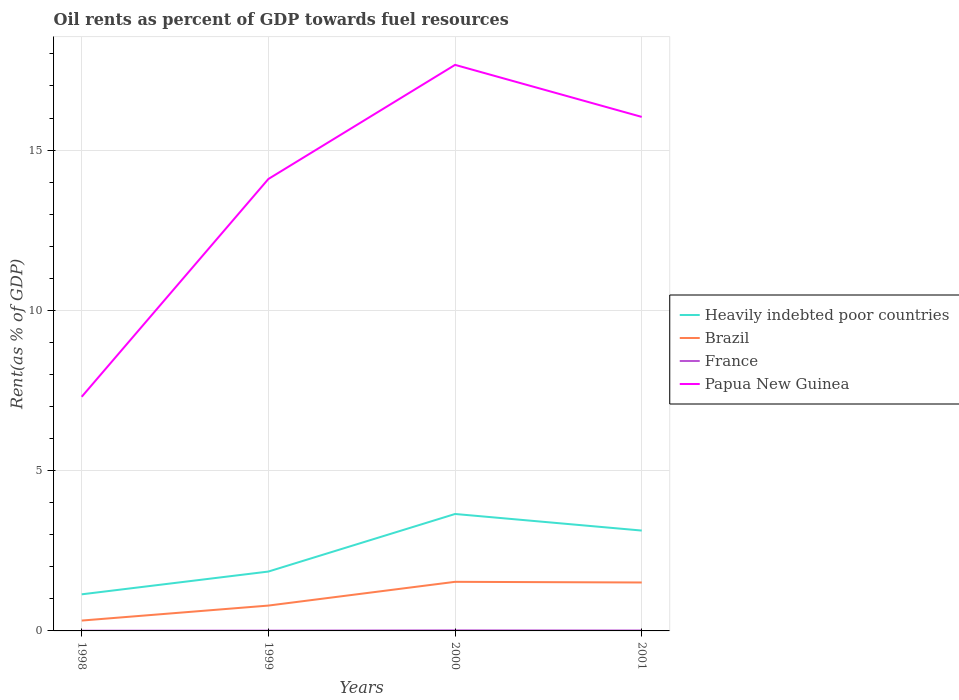Does the line corresponding to Brazil intersect with the line corresponding to Papua New Guinea?
Provide a succinct answer. No. Across all years, what is the maximum oil rent in Brazil?
Your response must be concise. 0.32. In which year was the oil rent in Heavily indebted poor countries maximum?
Provide a succinct answer. 1998. What is the total oil rent in Papua New Guinea in the graph?
Give a very brief answer. -6.79. What is the difference between the highest and the second highest oil rent in Brazil?
Ensure brevity in your answer.  1.21. Is the oil rent in France strictly greater than the oil rent in Papua New Guinea over the years?
Your response must be concise. Yes. How many lines are there?
Make the answer very short. 4. How are the legend labels stacked?
Give a very brief answer. Vertical. What is the title of the graph?
Your answer should be compact. Oil rents as percent of GDP towards fuel resources. Does "Tanzania" appear as one of the legend labels in the graph?
Offer a very short reply. No. What is the label or title of the Y-axis?
Your answer should be very brief. Rent(as % of GDP). What is the Rent(as % of GDP) of Heavily indebted poor countries in 1998?
Ensure brevity in your answer.  1.14. What is the Rent(as % of GDP) in Brazil in 1998?
Your answer should be very brief. 0.32. What is the Rent(as % of GDP) in France in 1998?
Your answer should be compact. 0.01. What is the Rent(as % of GDP) of Papua New Guinea in 1998?
Your answer should be compact. 7.3. What is the Rent(as % of GDP) of Heavily indebted poor countries in 1999?
Keep it short and to the point. 1.85. What is the Rent(as % of GDP) in Brazil in 1999?
Make the answer very short. 0.79. What is the Rent(as % of GDP) of France in 1999?
Your response must be concise. 0.01. What is the Rent(as % of GDP) of Papua New Guinea in 1999?
Your answer should be compact. 14.1. What is the Rent(as % of GDP) in Heavily indebted poor countries in 2000?
Your answer should be compact. 3.65. What is the Rent(as % of GDP) of Brazil in 2000?
Your answer should be compact. 1.53. What is the Rent(as % of GDP) in France in 2000?
Give a very brief answer. 0.02. What is the Rent(as % of GDP) of Papua New Guinea in 2000?
Give a very brief answer. 17.66. What is the Rent(as % of GDP) of Heavily indebted poor countries in 2001?
Your answer should be compact. 3.13. What is the Rent(as % of GDP) of Brazil in 2001?
Make the answer very short. 1.51. What is the Rent(as % of GDP) of France in 2001?
Offer a very short reply. 0.01. What is the Rent(as % of GDP) in Papua New Guinea in 2001?
Give a very brief answer. 16.03. Across all years, what is the maximum Rent(as % of GDP) of Heavily indebted poor countries?
Provide a succinct answer. 3.65. Across all years, what is the maximum Rent(as % of GDP) of Brazil?
Offer a terse response. 1.53. Across all years, what is the maximum Rent(as % of GDP) of France?
Keep it short and to the point. 0.02. Across all years, what is the maximum Rent(as % of GDP) of Papua New Guinea?
Give a very brief answer. 17.66. Across all years, what is the minimum Rent(as % of GDP) of Heavily indebted poor countries?
Give a very brief answer. 1.14. Across all years, what is the minimum Rent(as % of GDP) of Brazil?
Offer a very short reply. 0.32. Across all years, what is the minimum Rent(as % of GDP) in France?
Make the answer very short. 0.01. Across all years, what is the minimum Rent(as % of GDP) in Papua New Guinea?
Give a very brief answer. 7.3. What is the total Rent(as % of GDP) in Heavily indebted poor countries in the graph?
Your response must be concise. 9.77. What is the total Rent(as % of GDP) in Brazil in the graph?
Offer a terse response. 4.16. What is the total Rent(as % of GDP) of France in the graph?
Ensure brevity in your answer.  0.05. What is the total Rent(as % of GDP) in Papua New Guinea in the graph?
Your response must be concise. 55.09. What is the difference between the Rent(as % of GDP) of Heavily indebted poor countries in 1998 and that in 1999?
Give a very brief answer. -0.71. What is the difference between the Rent(as % of GDP) of Brazil in 1998 and that in 1999?
Provide a short and direct response. -0.47. What is the difference between the Rent(as % of GDP) in France in 1998 and that in 1999?
Provide a short and direct response. -0. What is the difference between the Rent(as % of GDP) of Papua New Guinea in 1998 and that in 1999?
Keep it short and to the point. -6.79. What is the difference between the Rent(as % of GDP) of Heavily indebted poor countries in 1998 and that in 2000?
Your answer should be compact. -2.51. What is the difference between the Rent(as % of GDP) of Brazil in 1998 and that in 2000?
Provide a short and direct response. -1.21. What is the difference between the Rent(as % of GDP) in France in 1998 and that in 2000?
Your answer should be compact. -0.01. What is the difference between the Rent(as % of GDP) in Papua New Guinea in 1998 and that in 2000?
Provide a short and direct response. -10.35. What is the difference between the Rent(as % of GDP) in Heavily indebted poor countries in 1998 and that in 2001?
Keep it short and to the point. -1.99. What is the difference between the Rent(as % of GDP) of Brazil in 1998 and that in 2001?
Make the answer very short. -1.19. What is the difference between the Rent(as % of GDP) of France in 1998 and that in 2001?
Make the answer very short. -0.01. What is the difference between the Rent(as % of GDP) in Papua New Guinea in 1998 and that in 2001?
Make the answer very short. -8.73. What is the difference between the Rent(as % of GDP) in Heavily indebted poor countries in 1999 and that in 2000?
Your response must be concise. -1.8. What is the difference between the Rent(as % of GDP) in Brazil in 1999 and that in 2000?
Ensure brevity in your answer.  -0.74. What is the difference between the Rent(as % of GDP) in France in 1999 and that in 2000?
Your answer should be very brief. -0.01. What is the difference between the Rent(as % of GDP) in Papua New Guinea in 1999 and that in 2000?
Make the answer very short. -3.56. What is the difference between the Rent(as % of GDP) in Heavily indebted poor countries in 1999 and that in 2001?
Your response must be concise. -1.28. What is the difference between the Rent(as % of GDP) of Brazil in 1999 and that in 2001?
Offer a very short reply. -0.72. What is the difference between the Rent(as % of GDP) in France in 1999 and that in 2001?
Ensure brevity in your answer.  -0. What is the difference between the Rent(as % of GDP) in Papua New Guinea in 1999 and that in 2001?
Make the answer very short. -1.94. What is the difference between the Rent(as % of GDP) in Heavily indebted poor countries in 2000 and that in 2001?
Your answer should be compact. 0.52. What is the difference between the Rent(as % of GDP) in Brazil in 2000 and that in 2001?
Give a very brief answer. 0.02. What is the difference between the Rent(as % of GDP) of France in 2000 and that in 2001?
Your response must be concise. 0. What is the difference between the Rent(as % of GDP) in Papua New Guinea in 2000 and that in 2001?
Keep it short and to the point. 1.62. What is the difference between the Rent(as % of GDP) of Heavily indebted poor countries in 1998 and the Rent(as % of GDP) of Brazil in 1999?
Keep it short and to the point. 0.35. What is the difference between the Rent(as % of GDP) in Heavily indebted poor countries in 1998 and the Rent(as % of GDP) in France in 1999?
Ensure brevity in your answer.  1.13. What is the difference between the Rent(as % of GDP) of Heavily indebted poor countries in 1998 and the Rent(as % of GDP) of Papua New Guinea in 1999?
Your answer should be very brief. -12.96. What is the difference between the Rent(as % of GDP) in Brazil in 1998 and the Rent(as % of GDP) in France in 1999?
Offer a terse response. 0.31. What is the difference between the Rent(as % of GDP) of Brazil in 1998 and the Rent(as % of GDP) of Papua New Guinea in 1999?
Offer a terse response. -13.78. What is the difference between the Rent(as % of GDP) of France in 1998 and the Rent(as % of GDP) of Papua New Guinea in 1999?
Make the answer very short. -14.09. What is the difference between the Rent(as % of GDP) of Heavily indebted poor countries in 1998 and the Rent(as % of GDP) of Brazil in 2000?
Your answer should be very brief. -0.39. What is the difference between the Rent(as % of GDP) in Heavily indebted poor countries in 1998 and the Rent(as % of GDP) in France in 2000?
Your answer should be compact. 1.12. What is the difference between the Rent(as % of GDP) of Heavily indebted poor countries in 1998 and the Rent(as % of GDP) of Papua New Guinea in 2000?
Your answer should be compact. -16.52. What is the difference between the Rent(as % of GDP) of Brazil in 1998 and the Rent(as % of GDP) of France in 2000?
Give a very brief answer. 0.31. What is the difference between the Rent(as % of GDP) in Brazil in 1998 and the Rent(as % of GDP) in Papua New Guinea in 2000?
Make the answer very short. -17.33. What is the difference between the Rent(as % of GDP) of France in 1998 and the Rent(as % of GDP) of Papua New Guinea in 2000?
Provide a succinct answer. -17.65. What is the difference between the Rent(as % of GDP) in Heavily indebted poor countries in 1998 and the Rent(as % of GDP) in Brazil in 2001?
Offer a terse response. -0.37. What is the difference between the Rent(as % of GDP) in Heavily indebted poor countries in 1998 and the Rent(as % of GDP) in France in 2001?
Your answer should be compact. 1.13. What is the difference between the Rent(as % of GDP) of Heavily indebted poor countries in 1998 and the Rent(as % of GDP) of Papua New Guinea in 2001?
Your answer should be very brief. -14.89. What is the difference between the Rent(as % of GDP) of Brazil in 1998 and the Rent(as % of GDP) of France in 2001?
Provide a short and direct response. 0.31. What is the difference between the Rent(as % of GDP) in Brazil in 1998 and the Rent(as % of GDP) in Papua New Guinea in 2001?
Provide a succinct answer. -15.71. What is the difference between the Rent(as % of GDP) of France in 1998 and the Rent(as % of GDP) of Papua New Guinea in 2001?
Offer a very short reply. -16.03. What is the difference between the Rent(as % of GDP) of Heavily indebted poor countries in 1999 and the Rent(as % of GDP) of Brazil in 2000?
Make the answer very short. 0.32. What is the difference between the Rent(as % of GDP) of Heavily indebted poor countries in 1999 and the Rent(as % of GDP) of France in 2000?
Provide a short and direct response. 1.83. What is the difference between the Rent(as % of GDP) in Heavily indebted poor countries in 1999 and the Rent(as % of GDP) in Papua New Guinea in 2000?
Give a very brief answer. -15.81. What is the difference between the Rent(as % of GDP) in Brazil in 1999 and the Rent(as % of GDP) in France in 2000?
Offer a terse response. 0.77. What is the difference between the Rent(as % of GDP) in Brazil in 1999 and the Rent(as % of GDP) in Papua New Guinea in 2000?
Make the answer very short. -16.87. What is the difference between the Rent(as % of GDP) in France in 1999 and the Rent(as % of GDP) in Papua New Guinea in 2000?
Make the answer very short. -17.65. What is the difference between the Rent(as % of GDP) of Heavily indebted poor countries in 1999 and the Rent(as % of GDP) of Brazil in 2001?
Ensure brevity in your answer.  0.34. What is the difference between the Rent(as % of GDP) of Heavily indebted poor countries in 1999 and the Rent(as % of GDP) of France in 2001?
Ensure brevity in your answer.  1.84. What is the difference between the Rent(as % of GDP) of Heavily indebted poor countries in 1999 and the Rent(as % of GDP) of Papua New Guinea in 2001?
Your answer should be compact. -14.18. What is the difference between the Rent(as % of GDP) of Brazil in 1999 and the Rent(as % of GDP) of France in 2001?
Offer a very short reply. 0.78. What is the difference between the Rent(as % of GDP) of Brazil in 1999 and the Rent(as % of GDP) of Papua New Guinea in 2001?
Ensure brevity in your answer.  -15.24. What is the difference between the Rent(as % of GDP) in France in 1999 and the Rent(as % of GDP) in Papua New Guinea in 2001?
Your response must be concise. -16.02. What is the difference between the Rent(as % of GDP) in Heavily indebted poor countries in 2000 and the Rent(as % of GDP) in Brazil in 2001?
Give a very brief answer. 2.14. What is the difference between the Rent(as % of GDP) in Heavily indebted poor countries in 2000 and the Rent(as % of GDP) in France in 2001?
Your response must be concise. 3.63. What is the difference between the Rent(as % of GDP) of Heavily indebted poor countries in 2000 and the Rent(as % of GDP) of Papua New Guinea in 2001?
Your answer should be very brief. -12.39. What is the difference between the Rent(as % of GDP) of Brazil in 2000 and the Rent(as % of GDP) of France in 2001?
Provide a succinct answer. 1.52. What is the difference between the Rent(as % of GDP) of Brazil in 2000 and the Rent(as % of GDP) of Papua New Guinea in 2001?
Give a very brief answer. -14.5. What is the difference between the Rent(as % of GDP) in France in 2000 and the Rent(as % of GDP) in Papua New Guinea in 2001?
Keep it short and to the point. -16.02. What is the average Rent(as % of GDP) in Heavily indebted poor countries per year?
Provide a succinct answer. 2.44. What is the average Rent(as % of GDP) in Brazil per year?
Offer a very short reply. 1.04. What is the average Rent(as % of GDP) in France per year?
Make the answer very short. 0.01. What is the average Rent(as % of GDP) in Papua New Guinea per year?
Your answer should be compact. 13.77. In the year 1998, what is the difference between the Rent(as % of GDP) in Heavily indebted poor countries and Rent(as % of GDP) in Brazil?
Provide a succinct answer. 0.82. In the year 1998, what is the difference between the Rent(as % of GDP) in Heavily indebted poor countries and Rent(as % of GDP) in France?
Your answer should be compact. 1.13. In the year 1998, what is the difference between the Rent(as % of GDP) in Heavily indebted poor countries and Rent(as % of GDP) in Papua New Guinea?
Give a very brief answer. -6.16. In the year 1998, what is the difference between the Rent(as % of GDP) of Brazil and Rent(as % of GDP) of France?
Ensure brevity in your answer.  0.32. In the year 1998, what is the difference between the Rent(as % of GDP) of Brazil and Rent(as % of GDP) of Papua New Guinea?
Provide a succinct answer. -6.98. In the year 1998, what is the difference between the Rent(as % of GDP) in France and Rent(as % of GDP) in Papua New Guinea?
Offer a terse response. -7.3. In the year 1999, what is the difference between the Rent(as % of GDP) of Heavily indebted poor countries and Rent(as % of GDP) of Brazil?
Your answer should be very brief. 1.06. In the year 1999, what is the difference between the Rent(as % of GDP) in Heavily indebted poor countries and Rent(as % of GDP) in France?
Provide a succinct answer. 1.84. In the year 1999, what is the difference between the Rent(as % of GDP) of Heavily indebted poor countries and Rent(as % of GDP) of Papua New Guinea?
Your answer should be very brief. -12.25. In the year 1999, what is the difference between the Rent(as % of GDP) of Brazil and Rent(as % of GDP) of France?
Your answer should be compact. 0.78. In the year 1999, what is the difference between the Rent(as % of GDP) of Brazil and Rent(as % of GDP) of Papua New Guinea?
Your answer should be very brief. -13.31. In the year 1999, what is the difference between the Rent(as % of GDP) in France and Rent(as % of GDP) in Papua New Guinea?
Your answer should be very brief. -14.09. In the year 2000, what is the difference between the Rent(as % of GDP) of Heavily indebted poor countries and Rent(as % of GDP) of Brazil?
Your answer should be compact. 2.12. In the year 2000, what is the difference between the Rent(as % of GDP) in Heavily indebted poor countries and Rent(as % of GDP) in France?
Keep it short and to the point. 3.63. In the year 2000, what is the difference between the Rent(as % of GDP) of Heavily indebted poor countries and Rent(as % of GDP) of Papua New Guinea?
Your answer should be very brief. -14.01. In the year 2000, what is the difference between the Rent(as % of GDP) in Brazil and Rent(as % of GDP) in France?
Keep it short and to the point. 1.51. In the year 2000, what is the difference between the Rent(as % of GDP) in Brazil and Rent(as % of GDP) in Papua New Guinea?
Ensure brevity in your answer.  -16.13. In the year 2000, what is the difference between the Rent(as % of GDP) in France and Rent(as % of GDP) in Papua New Guinea?
Your answer should be very brief. -17.64. In the year 2001, what is the difference between the Rent(as % of GDP) in Heavily indebted poor countries and Rent(as % of GDP) in Brazil?
Ensure brevity in your answer.  1.62. In the year 2001, what is the difference between the Rent(as % of GDP) in Heavily indebted poor countries and Rent(as % of GDP) in France?
Your answer should be compact. 3.12. In the year 2001, what is the difference between the Rent(as % of GDP) in Heavily indebted poor countries and Rent(as % of GDP) in Papua New Guinea?
Provide a succinct answer. -12.9. In the year 2001, what is the difference between the Rent(as % of GDP) in Brazil and Rent(as % of GDP) in France?
Keep it short and to the point. 1.5. In the year 2001, what is the difference between the Rent(as % of GDP) in Brazil and Rent(as % of GDP) in Papua New Guinea?
Offer a terse response. -14.52. In the year 2001, what is the difference between the Rent(as % of GDP) of France and Rent(as % of GDP) of Papua New Guinea?
Provide a short and direct response. -16.02. What is the ratio of the Rent(as % of GDP) in Heavily indebted poor countries in 1998 to that in 1999?
Your response must be concise. 0.62. What is the ratio of the Rent(as % of GDP) of Brazil in 1998 to that in 1999?
Keep it short and to the point. 0.41. What is the ratio of the Rent(as % of GDP) in France in 1998 to that in 1999?
Make the answer very short. 0.74. What is the ratio of the Rent(as % of GDP) of Papua New Guinea in 1998 to that in 1999?
Your answer should be very brief. 0.52. What is the ratio of the Rent(as % of GDP) in Heavily indebted poor countries in 1998 to that in 2000?
Your answer should be very brief. 0.31. What is the ratio of the Rent(as % of GDP) in Brazil in 1998 to that in 2000?
Your answer should be very brief. 0.21. What is the ratio of the Rent(as % of GDP) of France in 1998 to that in 2000?
Provide a succinct answer. 0.4. What is the ratio of the Rent(as % of GDP) in Papua New Guinea in 1998 to that in 2000?
Keep it short and to the point. 0.41. What is the ratio of the Rent(as % of GDP) of Heavily indebted poor countries in 1998 to that in 2001?
Keep it short and to the point. 0.36. What is the ratio of the Rent(as % of GDP) of Brazil in 1998 to that in 2001?
Your answer should be very brief. 0.21. What is the ratio of the Rent(as % of GDP) of France in 1998 to that in 2001?
Provide a succinct answer. 0.51. What is the ratio of the Rent(as % of GDP) in Papua New Guinea in 1998 to that in 2001?
Keep it short and to the point. 0.46. What is the ratio of the Rent(as % of GDP) of Heavily indebted poor countries in 1999 to that in 2000?
Provide a short and direct response. 0.51. What is the ratio of the Rent(as % of GDP) of Brazil in 1999 to that in 2000?
Give a very brief answer. 0.52. What is the ratio of the Rent(as % of GDP) of France in 1999 to that in 2000?
Offer a very short reply. 0.54. What is the ratio of the Rent(as % of GDP) of Papua New Guinea in 1999 to that in 2000?
Your answer should be compact. 0.8. What is the ratio of the Rent(as % of GDP) in Heavily indebted poor countries in 1999 to that in 2001?
Offer a very short reply. 0.59. What is the ratio of the Rent(as % of GDP) in Brazil in 1999 to that in 2001?
Make the answer very short. 0.52. What is the ratio of the Rent(as % of GDP) in France in 1999 to that in 2001?
Your answer should be very brief. 0.69. What is the ratio of the Rent(as % of GDP) of Papua New Guinea in 1999 to that in 2001?
Your answer should be compact. 0.88. What is the ratio of the Rent(as % of GDP) in Heavily indebted poor countries in 2000 to that in 2001?
Your answer should be compact. 1.17. What is the ratio of the Rent(as % of GDP) of Brazil in 2000 to that in 2001?
Provide a succinct answer. 1.01. What is the ratio of the Rent(as % of GDP) in France in 2000 to that in 2001?
Your answer should be very brief. 1.28. What is the ratio of the Rent(as % of GDP) in Papua New Guinea in 2000 to that in 2001?
Your response must be concise. 1.1. What is the difference between the highest and the second highest Rent(as % of GDP) of Heavily indebted poor countries?
Provide a succinct answer. 0.52. What is the difference between the highest and the second highest Rent(as % of GDP) in Brazil?
Your answer should be compact. 0.02. What is the difference between the highest and the second highest Rent(as % of GDP) of France?
Your answer should be compact. 0. What is the difference between the highest and the second highest Rent(as % of GDP) in Papua New Guinea?
Your answer should be very brief. 1.62. What is the difference between the highest and the lowest Rent(as % of GDP) in Heavily indebted poor countries?
Your answer should be compact. 2.51. What is the difference between the highest and the lowest Rent(as % of GDP) of Brazil?
Your response must be concise. 1.21. What is the difference between the highest and the lowest Rent(as % of GDP) in France?
Make the answer very short. 0.01. What is the difference between the highest and the lowest Rent(as % of GDP) in Papua New Guinea?
Provide a succinct answer. 10.35. 